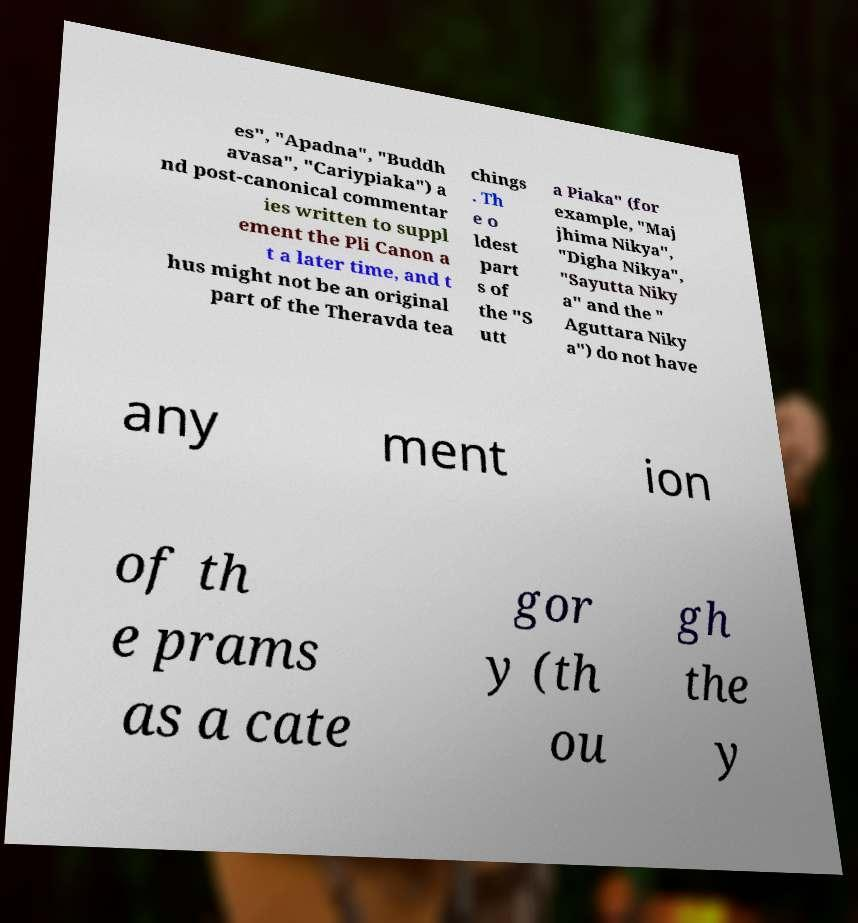Can you accurately transcribe the text from the provided image for me? es", "Apadna", "Buddh avasa", "Cariypiaka") a nd post-canonical commentar ies written to suppl ement the Pli Canon a t a later time, and t hus might not be an original part of the Theravda tea chings . Th e o ldest part s of the "S utt a Piaka" (for example, "Maj jhima Nikya", "Digha Nikya", "Sayutta Niky a" and the " Aguttara Niky a") do not have any ment ion of th e prams as a cate gor y (th ou gh the y 